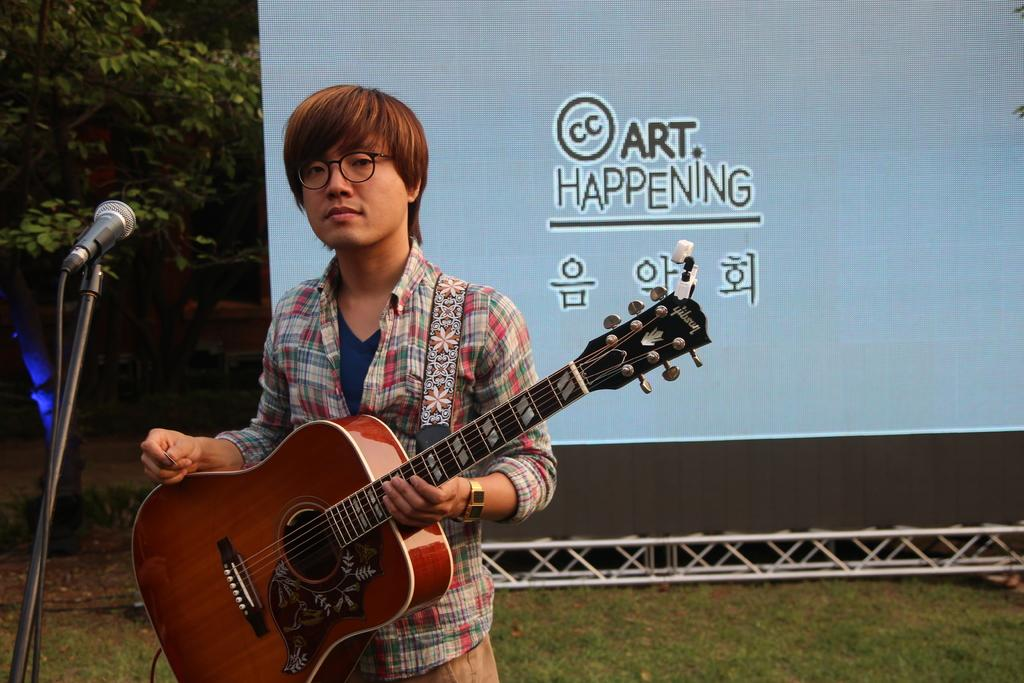What is the person in the image doing? The person is standing in the image and holding a guitar. What can be seen on the person's face? The person is wearing glasses. What equipment is in front of the person? There is a microphone with a stand in front of the person. What is visible in the background of the image? There is a banner and trees in the background of the image. How many kitties are sitting on the person's shoulders in the image? There are no kitties present in the image. What type of insect can be seen crawling on the guitar strings in the image? There are no insects visible on the guitar strings in the image. 